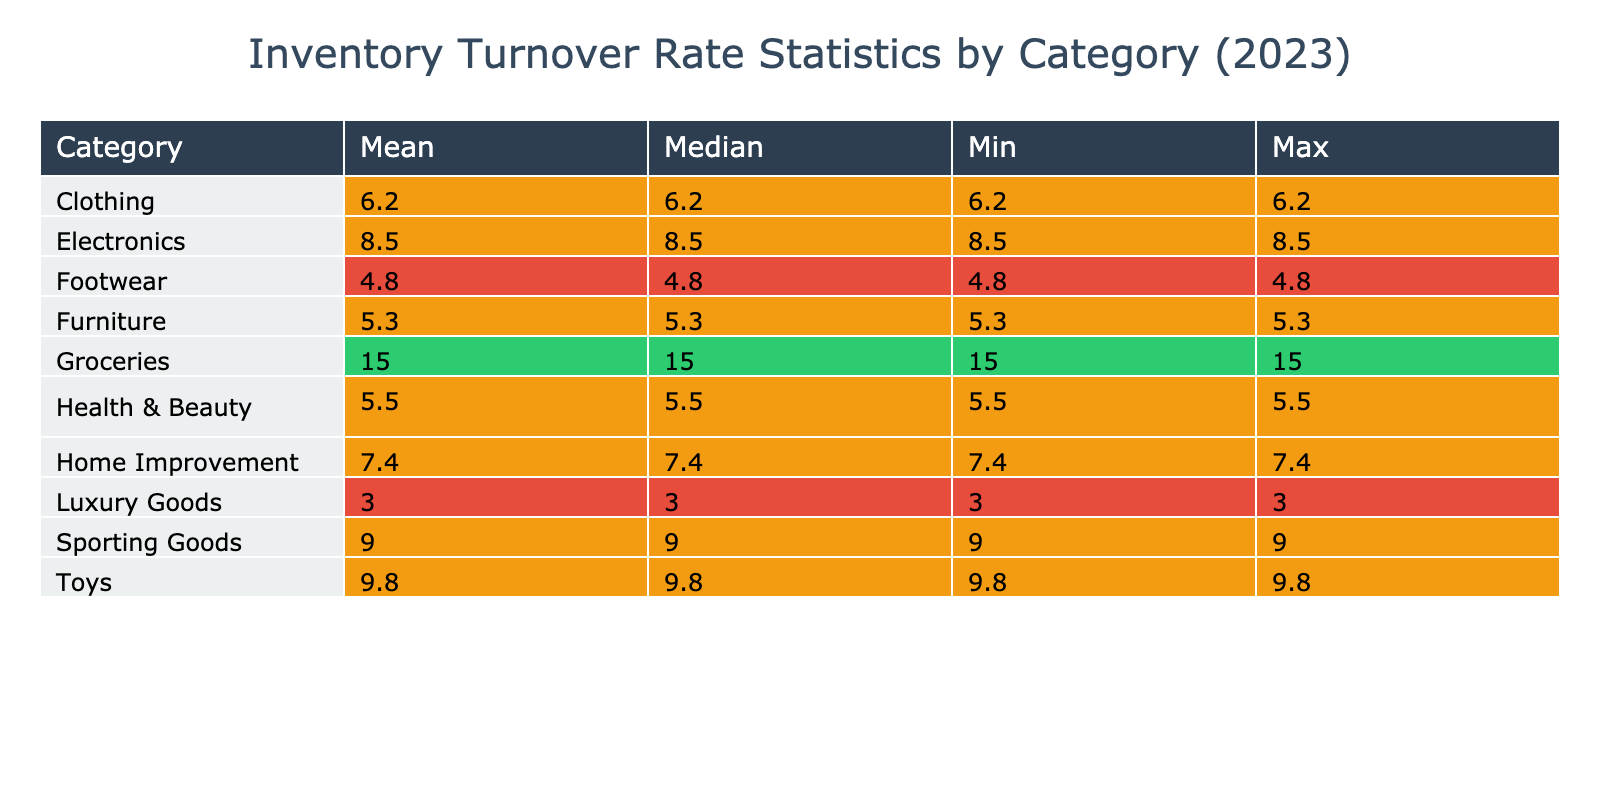What is the inventory turnover rate for Walmart? The table lists the inventory turnover rate for each store. For Walmart, the rate is explicitly stated under the Groceries category as 15.0.
Answer: 15.0 Which category has the highest mean inventory turnover rate? The summary statistics in the table include the mean for each category. By comparing these means, Groceries has the highest mean at 15.0.
Answer: Groceries Is the median inventory turnover rate for Sporting Goods greater than 8? The median for Sporting Goods is listed in the table as 9.0, which is indeed greater than 8.
Answer: Yes What is the difference between the maximum and minimum inventory turnover rates in the Clothing category? In the Clothing category, the maximum is not provided in the detailed data, but we have a median of 6.2. Since there's no explicit min/max in the data, we assume the maximum and minimum are equal to the median due to lack of variance information. Thus, the difference is 0.
Answer: 0 If we combine the inventory turnover rates for Health & Beauty and Footwear, what is their average? The turnover rates are 5.5 for Health & Beauty and 4.8 for Footwear. We sum them: 5.5 + 4.8 = 10.3, then divide by 2 (since there are 2 categories), giving us an average of 5.15.
Answer: 5.15 